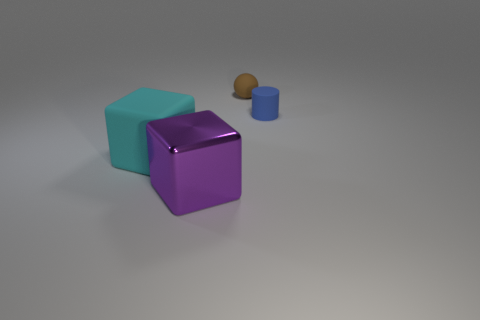Is the number of things on the right side of the large matte block greater than the number of big cyan rubber blocks?
Ensure brevity in your answer.  Yes. There is a thing that is left of the tiny blue thing and right of the purple cube; what size is it?
Give a very brief answer. Small. What is the material of the other large object that is the same shape as the large cyan thing?
Provide a short and direct response. Metal. Does the matte thing that is right of the brown rubber sphere have the same size as the big cyan rubber thing?
Ensure brevity in your answer.  No. What color is the rubber object that is to the right of the large cyan rubber block and left of the cylinder?
Your answer should be compact. Brown. There is a tiny thing to the left of the small blue thing; how many big cyan objects are behind it?
Ensure brevity in your answer.  0. Is the shape of the large rubber thing the same as the purple object?
Keep it short and to the point. Yes. Is there anything else that is the same color as the rubber cylinder?
Ensure brevity in your answer.  No. Is the shape of the metallic object the same as the large thing that is behind the purple block?
Provide a succinct answer. Yes. There is a tiny object that is left of the blue matte object right of the cube that is behind the purple metal thing; what color is it?
Your response must be concise. Brown. 